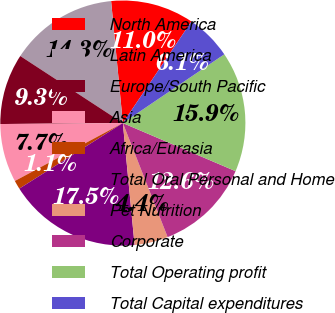Convert chart. <chart><loc_0><loc_0><loc_500><loc_500><pie_chart><fcel>North America<fcel>Latin America<fcel>Europe/South Pacific<fcel>Asia<fcel>Africa/Eurasia<fcel>Total Oral Personal and Home<fcel>Pet Nutrition<fcel>Corporate<fcel>Total Operating profit<fcel>Total Capital expenditures<nl><fcel>10.98%<fcel>14.26%<fcel>9.34%<fcel>7.71%<fcel>1.15%<fcel>17.54%<fcel>4.43%<fcel>12.62%<fcel>15.9%<fcel>6.07%<nl></chart> 